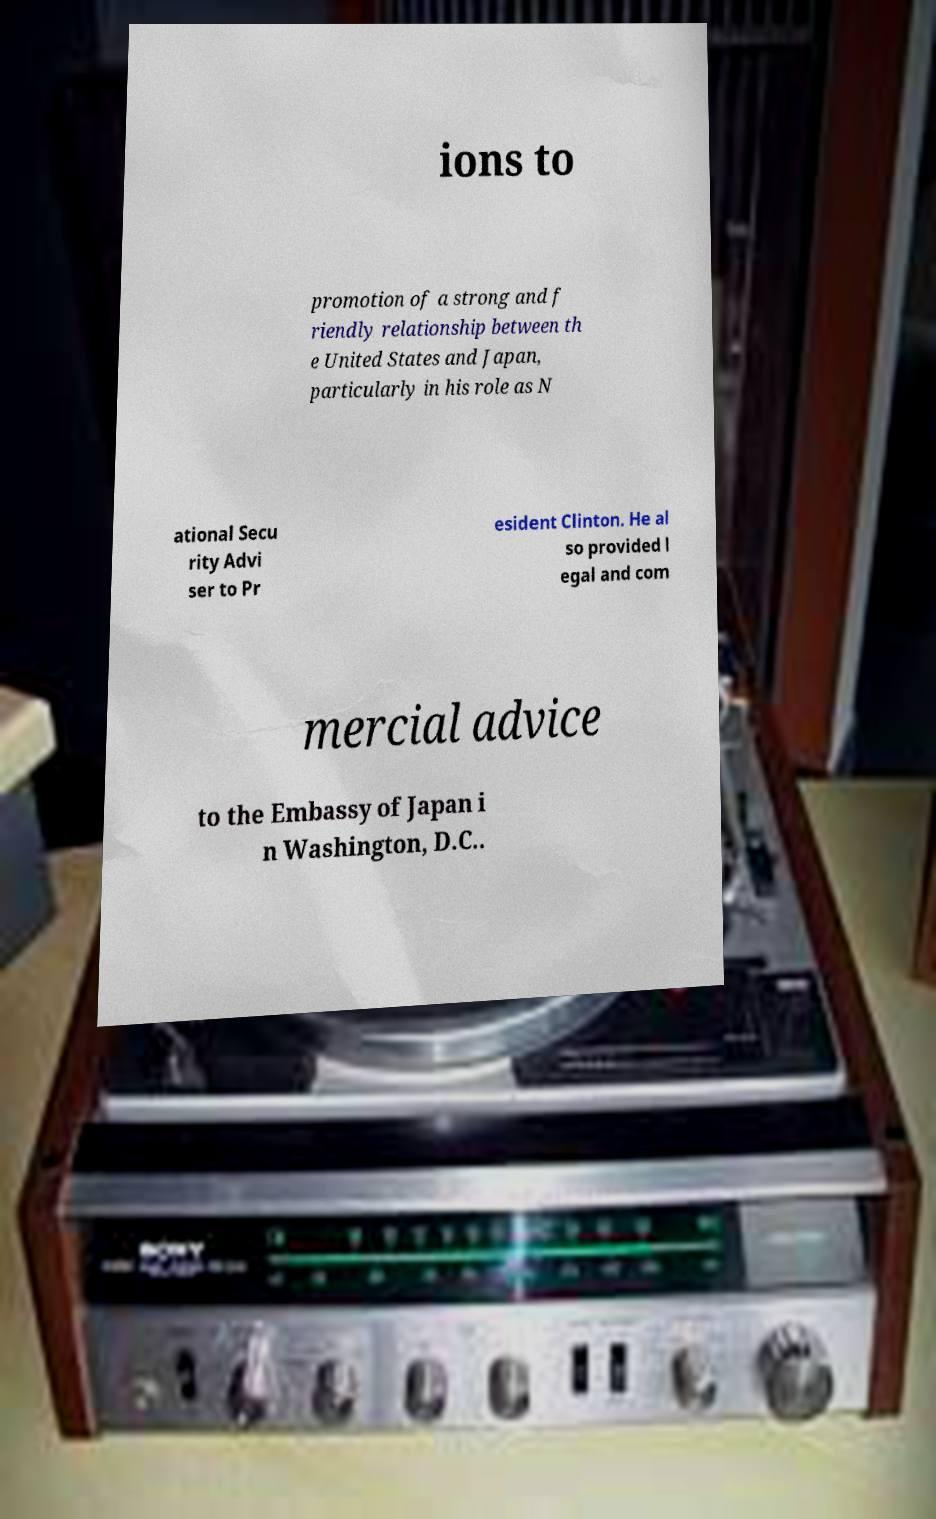I need the written content from this picture converted into text. Can you do that? ions to promotion of a strong and f riendly relationship between th e United States and Japan, particularly in his role as N ational Secu rity Advi ser to Pr esident Clinton. He al so provided l egal and com mercial advice to the Embassy of Japan i n Washington, D.C.. 